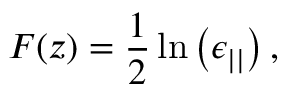Convert formula to latex. <formula><loc_0><loc_0><loc_500><loc_500>F ( z ) = \frac { 1 } { 2 } \ln \left ( \epsilon _ { | | } \right ) ,</formula> 